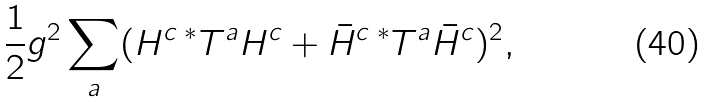Convert formula to latex. <formula><loc_0><loc_0><loc_500><loc_500>\frac { 1 } { 2 } g ^ { 2 } \sum _ { a } ( H ^ { c } \, ^ { * } T ^ { a } H ^ { c } + \bar { H } ^ { c } \, ^ { * } T ^ { a } \bar { H } ^ { c } ) ^ { 2 } ,</formula> 